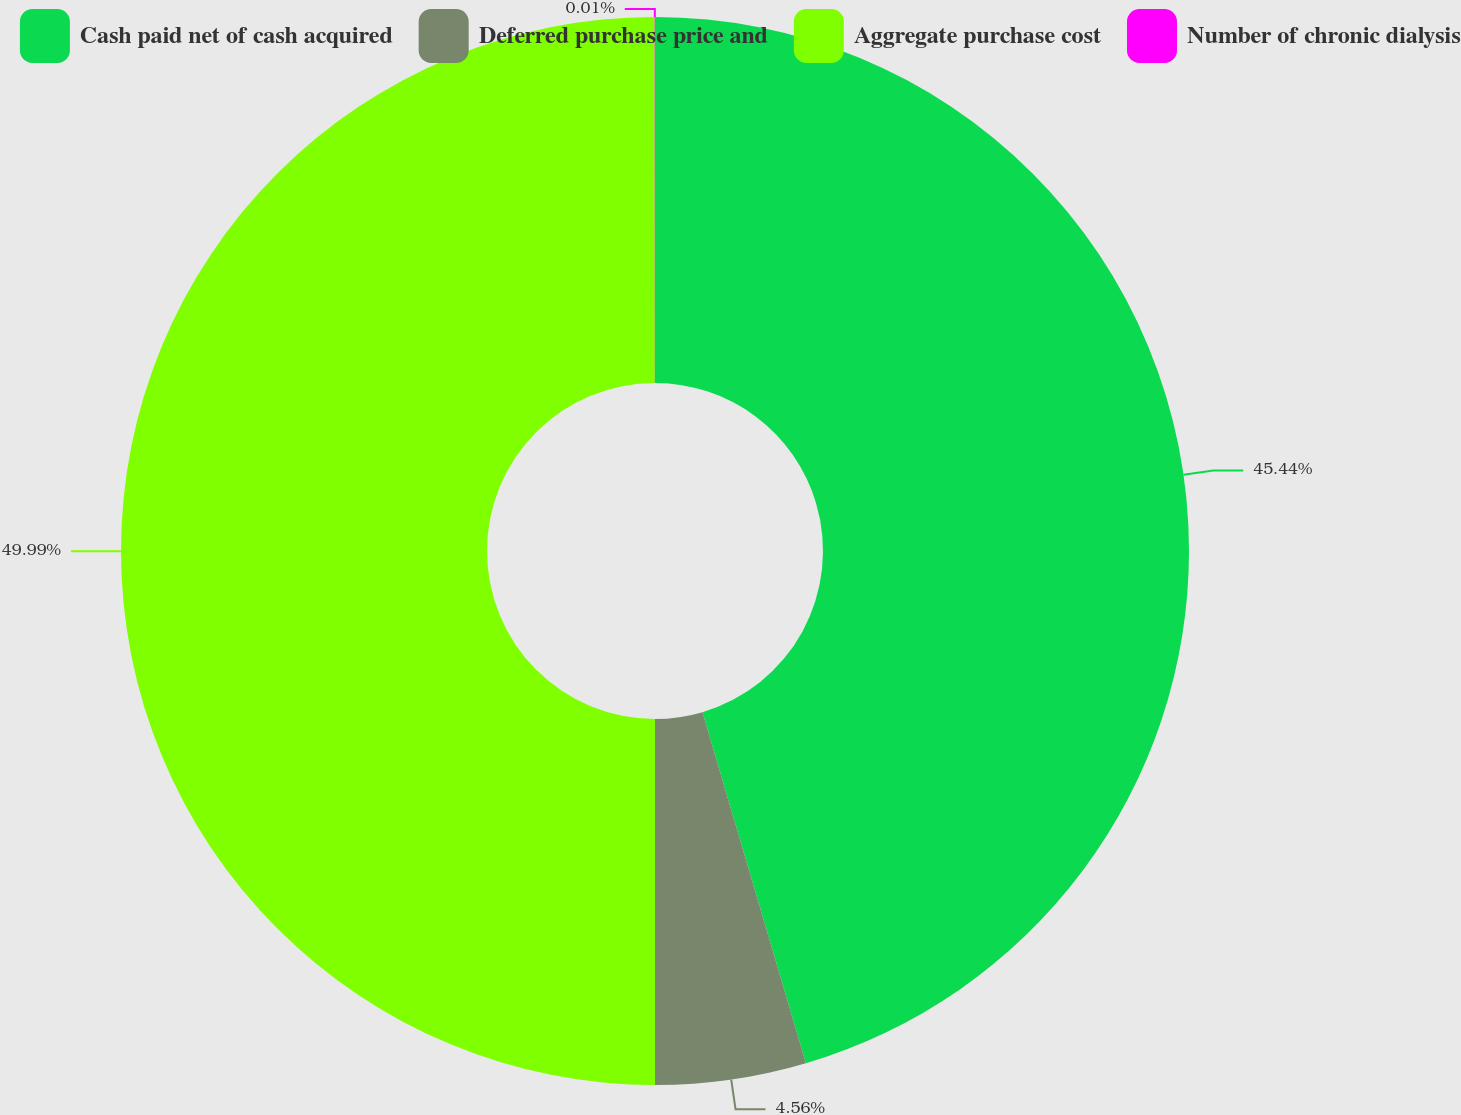Convert chart. <chart><loc_0><loc_0><loc_500><loc_500><pie_chart><fcel>Cash paid net of cash acquired<fcel>Deferred purchase price and<fcel>Aggregate purchase cost<fcel>Number of chronic dialysis<nl><fcel>45.44%<fcel>4.56%<fcel>49.99%<fcel>0.01%<nl></chart> 